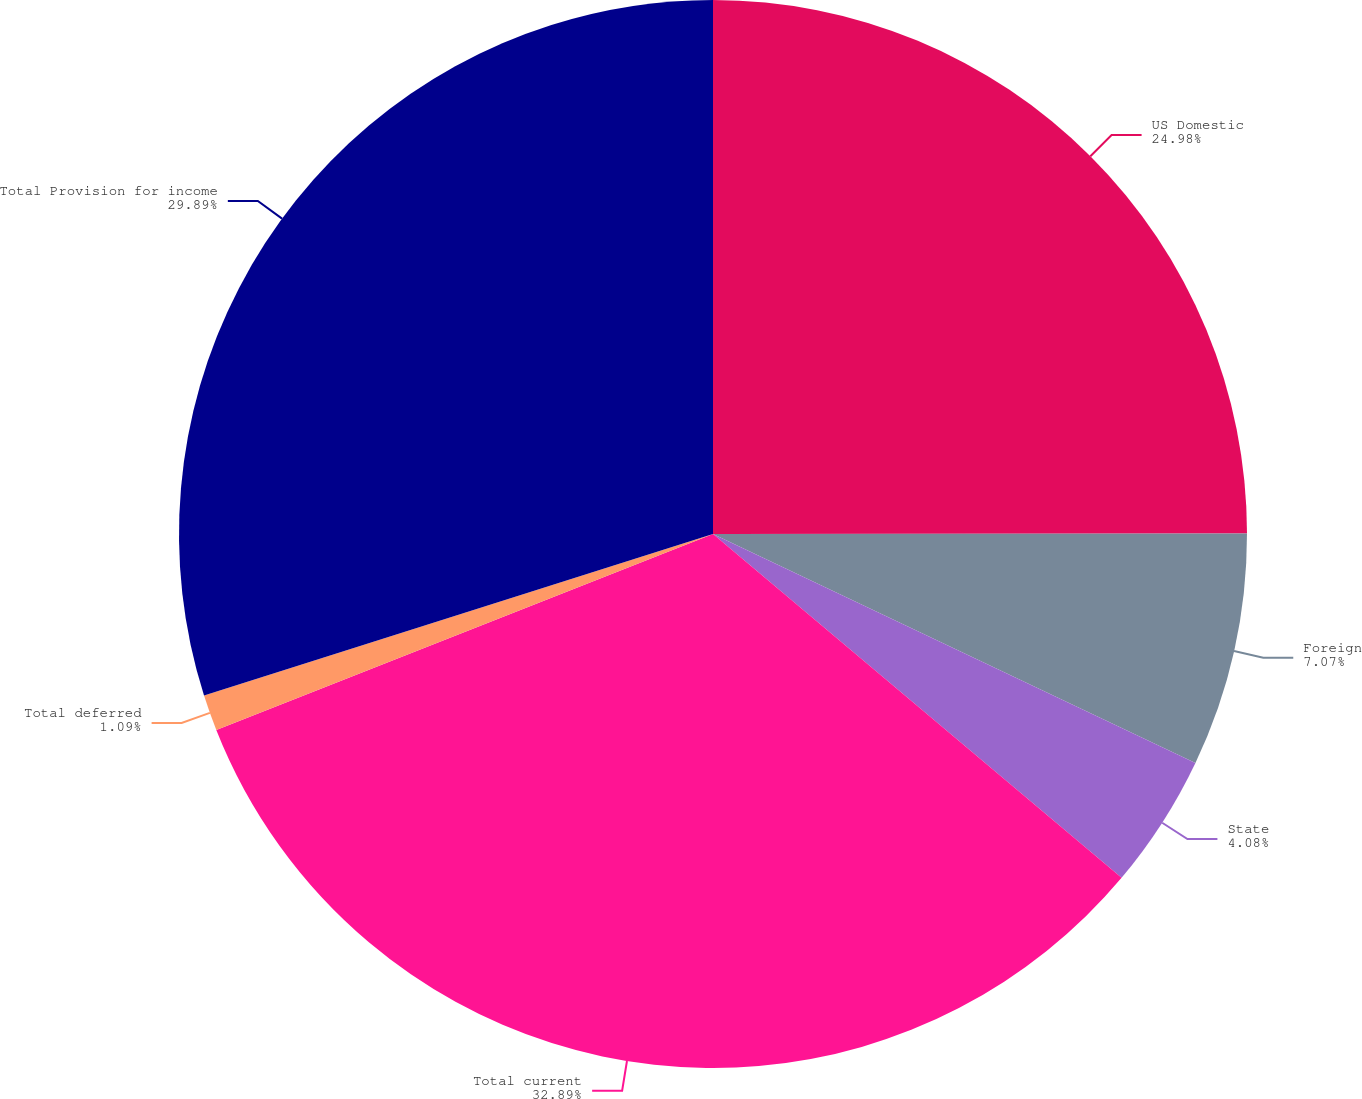Convert chart to OTSL. <chart><loc_0><loc_0><loc_500><loc_500><pie_chart><fcel>US Domestic<fcel>Foreign<fcel>State<fcel>Total current<fcel>Total deferred<fcel>Total Provision for income<nl><fcel>24.98%<fcel>7.07%<fcel>4.08%<fcel>32.88%<fcel>1.09%<fcel>29.89%<nl></chart> 